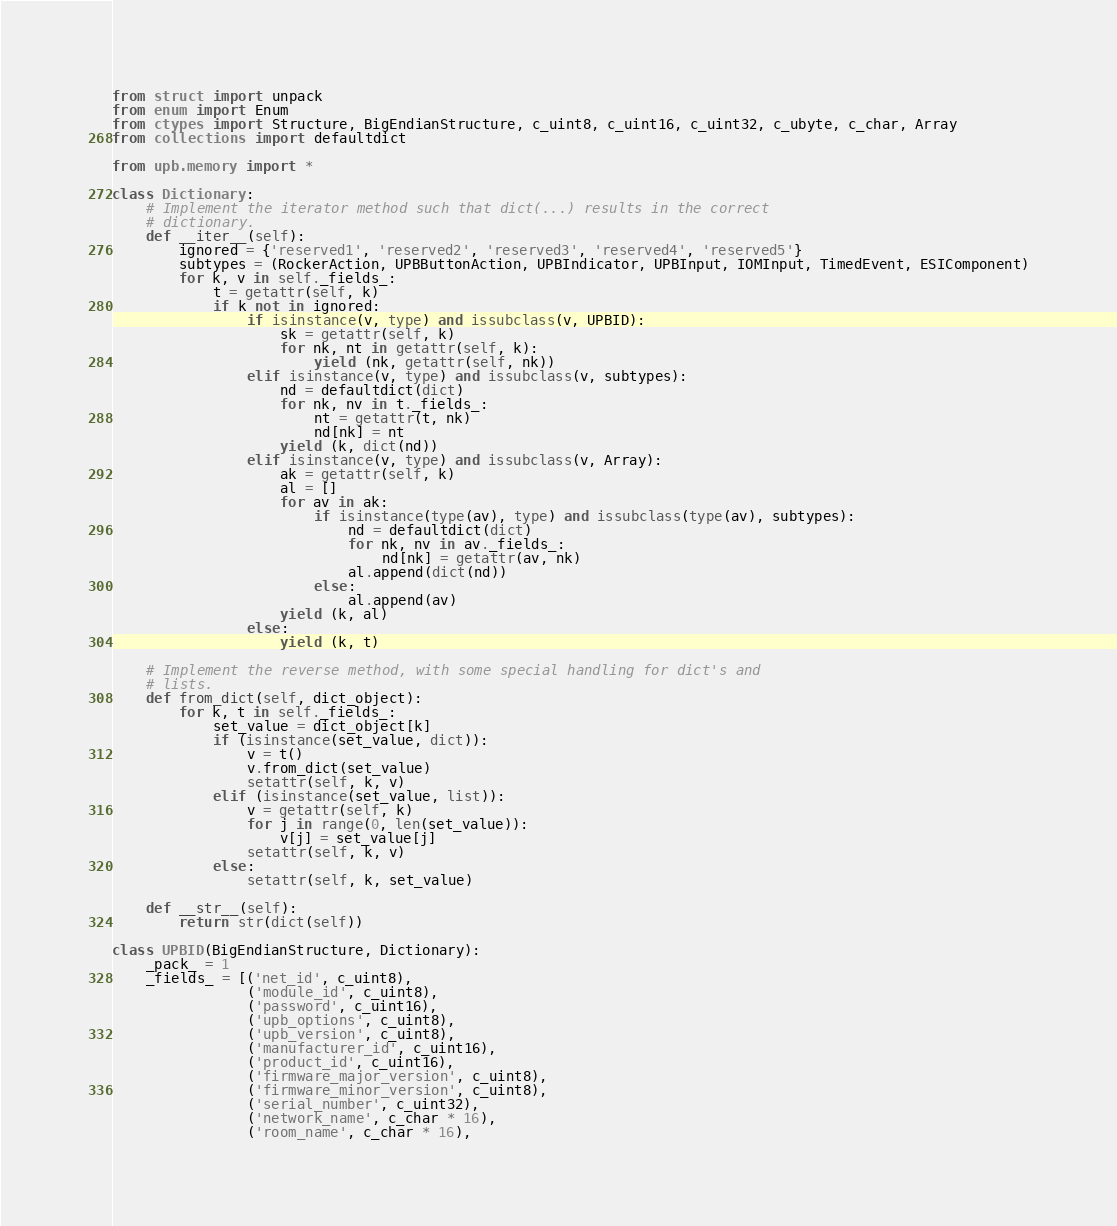<code> <loc_0><loc_0><loc_500><loc_500><_Python_>from struct import unpack
from enum import Enum
from ctypes import Structure, BigEndianStructure, c_uint8, c_uint16, c_uint32, c_ubyte, c_char, Array
from collections import defaultdict

from upb.memory import *

class Dictionary:
    # Implement the iterator method such that dict(...) results in the correct
    # dictionary.
    def __iter__(self):
        ignored = {'reserved1', 'reserved2', 'reserved3', 'reserved4', 'reserved5'}
        subtypes = (RockerAction, UPBButtonAction, UPBIndicator, UPBInput, IOMInput, TimedEvent, ESIComponent)
        for k, v in self._fields_:
            t = getattr(self, k)
            if k not in ignored:
                if isinstance(v, type) and issubclass(v, UPBID):
                    sk = getattr(self, k)
                    for nk, nt in getattr(self, k):
                        yield (nk, getattr(self, nk))
                elif isinstance(v, type) and issubclass(v, subtypes):
                    nd = defaultdict(dict)
                    for nk, nv in t._fields_:
                        nt = getattr(t, nk)
                        nd[nk] = nt
                    yield (k, dict(nd))
                elif isinstance(v, type) and issubclass(v, Array):
                    ak = getattr(self, k)
                    al = []
                    for av in ak:
                        if isinstance(type(av), type) and issubclass(type(av), subtypes):
                            nd = defaultdict(dict)
                            for nk, nv in av._fields_:
                                nd[nk] = getattr(av, nk)
                            al.append(dict(nd))
                        else:
                            al.append(av)
                    yield (k, al)
                else:
                    yield (k, t)

    # Implement the reverse method, with some special handling for dict's and
    # lists.
    def from_dict(self, dict_object):
        for k, t in self._fields_:
            set_value = dict_object[k]
            if (isinstance(set_value, dict)):
                v = t()
                v.from_dict(set_value)
                setattr(self, k, v)
            elif (isinstance(set_value, list)):
                v = getattr(self, k)
                for j in range(0, len(set_value)):
                    v[j] = set_value[j]
                setattr(self, k, v)
            else:
                setattr(self, k, set_value)

    def __str__(self):
        return str(dict(self))

class UPBID(BigEndianStructure, Dictionary):
    _pack_ = 1
    _fields_ = [('net_id', c_uint8),
                ('module_id', c_uint8),
                ('password', c_uint16),
                ('upb_options', c_uint8),
                ('upb_version', c_uint8),
                ('manufacturer_id', c_uint16),
                ('product_id', c_uint16),
                ('firmware_major_version', c_uint8),
                ('firmware_minor_version', c_uint8),
                ('serial_number', c_uint32),
                ('network_name', c_char * 16),
                ('room_name', c_char * 16),</code> 